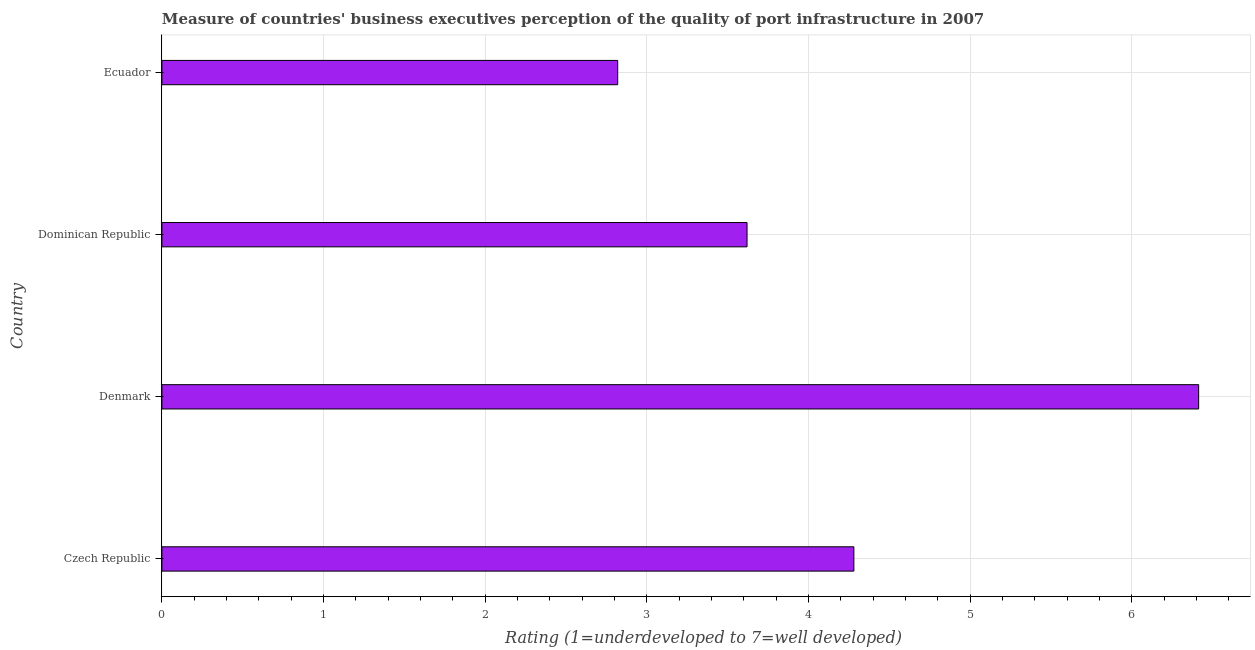Does the graph contain any zero values?
Your response must be concise. No. What is the title of the graph?
Your answer should be very brief. Measure of countries' business executives perception of the quality of port infrastructure in 2007. What is the label or title of the X-axis?
Your answer should be very brief. Rating (1=underdeveloped to 7=well developed) . What is the label or title of the Y-axis?
Your answer should be compact. Country. What is the rating measuring quality of port infrastructure in Dominican Republic?
Offer a terse response. 3.62. Across all countries, what is the maximum rating measuring quality of port infrastructure?
Ensure brevity in your answer.  6.41. Across all countries, what is the minimum rating measuring quality of port infrastructure?
Your answer should be very brief. 2.82. In which country was the rating measuring quality of port infrastructure maximum?
Your answer should be compact. Denmark. In which country was the rating measuring quality of port infrastructure minimum?
Ensure brevity in your answer.  Ecuador. What is the sum of the rating measuring quality of port infrastructure?
Provide a succinct answer. 17.13. What is the difference between the rating measuring quality of port infrastructure in Czech Republic and Denmark?
Keep it short and to the point. -2.13. What is the average rating measuring quality of port infrastructure per country?
Offer a very short reply. 4.28. What is the median rating measuring quality of port infrastructure?
Your answer should be very brief. 3.95. In how many countries, is the rating measuring quality of port infrastructure greater than 3.8 ?
Keep it short and to the point. 2. What is the ratio of the rating measuring quality of port infrastructure in Czech Republic to that in Ecuador?
Ensure brevity in your answer.  1.52. Is the rating measuring quality of port infrastructure in Dominican Republic less than that in Ecuador?
Provide a succinct answer. No. What is the difference between the highest and the second highest rating measuring quality of port infrastructure?
Your answer should be very brief. 2.13. Is the sum of the rating measuring quality of port infrastructure in Czech Republic and Denmark greater than the maximum rating measuring quality of port infrastructure across all countries?
Give a very brief answer. Yes. What is the difference between the highest and the lowest rating measuring quality of port infrastructure?
Your answer should be compact. 3.59. In how many countries, is the rating measuring quality of port infrastructure greater than the average rating measuring quality of port infrastructure taken over all countries?
Offer a very short reply. 1. Are all the bars in the graph horizontal?
Your answer should be very brief. Yes. What is the Rating (1=underdeveloped to 7=well developed)  of Czech Republic?
Provide a short and direct response. 4.28. What is the Rating (1=underdeveloped to 7=well developed)  of Denmark?
Provide a short and direct response. 6.41. What is the Rating (1=underdeveloped to 7=well developed)  of Dominican Republic?
Your response must be concise. 3.62. What is the Rating (1=underdeveloped to 7=well developed)  in Ecuador?
Provide a short and direct response. 2.82. What is the difference between the Rating (1=underdeveloped to 7=well developed)  in Czech Republic and Denmark?
Offer a terse response. -2.13. What is the difference between the Rating (1=underdeveloped to 7=well developed)  in Czech Republic and Dominican Republic?
Ensure brevity in your answer.  0.66. What is the difference between the Rating (1=underdeveloped to 7=well developed)  in Czech Republic and Ecuador?
Your response must be concise. 1.46. What is the difference between the Rating (1=underdeveloped to 7=well developed)  in Denmark and Dominican Republic?
Give a very brief answer. 2.79. What is the difference between the Rating (1=underdeveloped to 7=well developed)  in Denmark and Ecuador?
Offer a terse response. 3.59. What is the difference between the Rating (1=underdeveloped to 7=well developed)  in Dominican Republic and Ecuador?
Keep it short and to the point. 0.8. What is the ratio of the Rating (1=underdeveloped to 7=well developed)  in Czech Republic to that in Denmark?
Your answer should be compact. 0.67. What is the ratio of the Rating (1=underdeveloped to 7=well developed)  in Czech Republic to that in Dominican Republic?
Provide a succinct answer. 1.18. What is the ratio of the Rating (1=underdeveloped to 7=well developed)  in Czech Republic to that in Ecuador?
Provide a short and direct response. 1.52. What is the ratio of the Rating (1=underdeveloped to 7=well developed)  in Denmark to that in Dominican Republic?
Keep it short and to the point. 1.77. What is the ratio of the Rating (1=underdeveloped to 7=well developed)  in Denmark to that in Ecuador?
Your response must be concise. 2.27. What is the ratio of the Rating (1=underdeveloped to 7=well developed)  in Dominican Republic to that in Ecuador?
Keep it short and to the point. 1.28. 